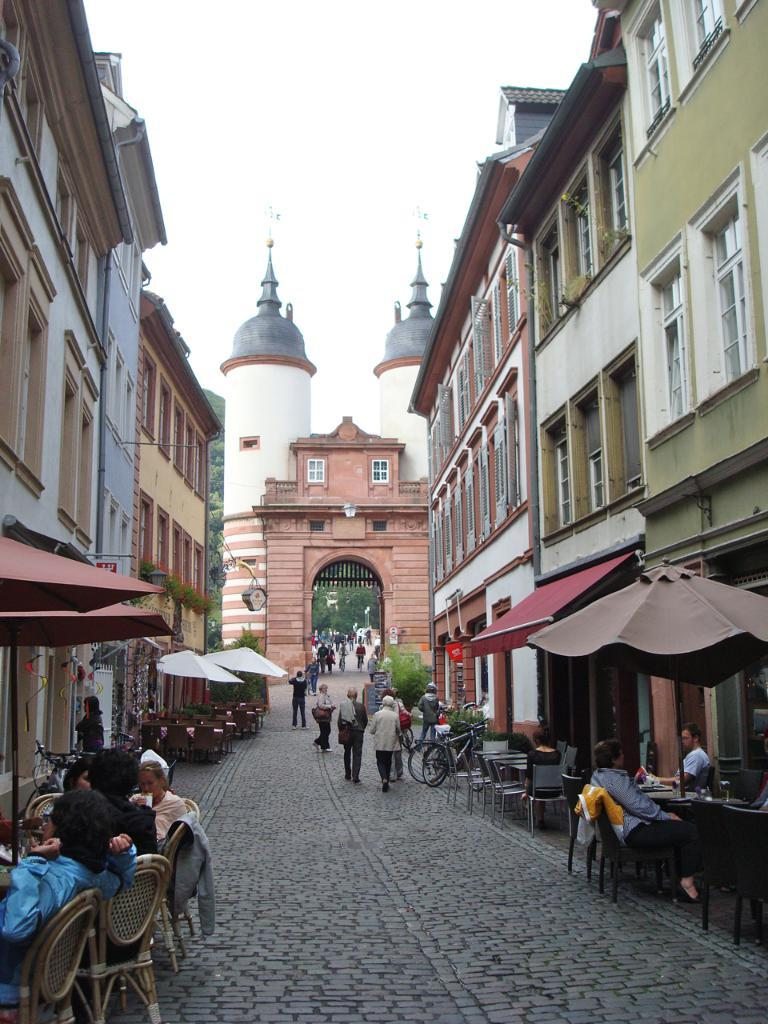What type of structures can be seen in the image? There are buildings in the image. What type of furniture is present in the image? There are tables and chairs in the image. Are there any people in the image? Yes, there are people in the image. What is visible at the top of the image? The sky is visible at the top of the image. How many hands are visible in the image? There is no mention of hands in the provided facts, so we cannot determine the number of hands visible in the image. 